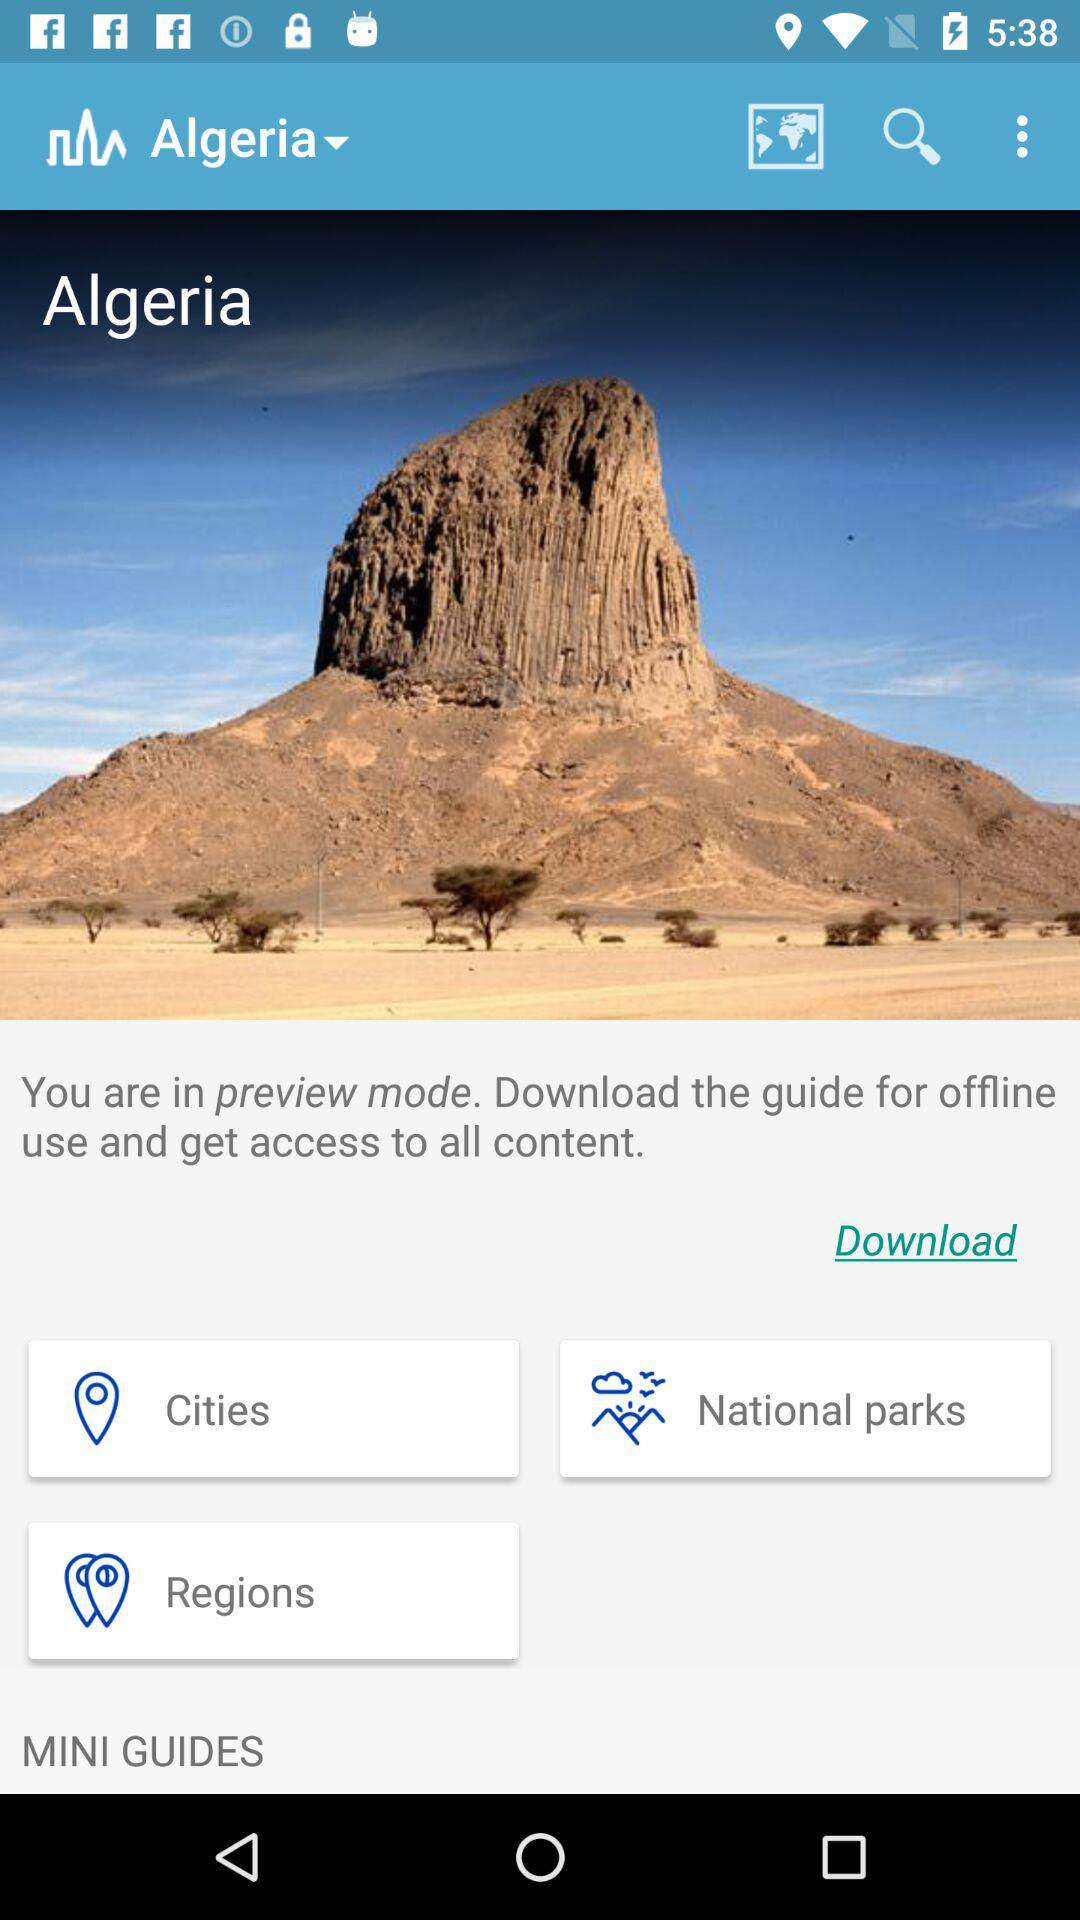What's the current view mode? The current view mode is preview. 